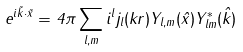<formula> <loc_0><loc_0><loc_500><loc_500>e ^ { i \vec { k } \cdot \vec { x } } = 4 \pi \sum _ { l , m } i ^ { l } j _ { l } ( k r ) Y _ { l , m } ( \hat { x } ) Y ^ { * } _ { l m } ( \hat { k } )</formula> 